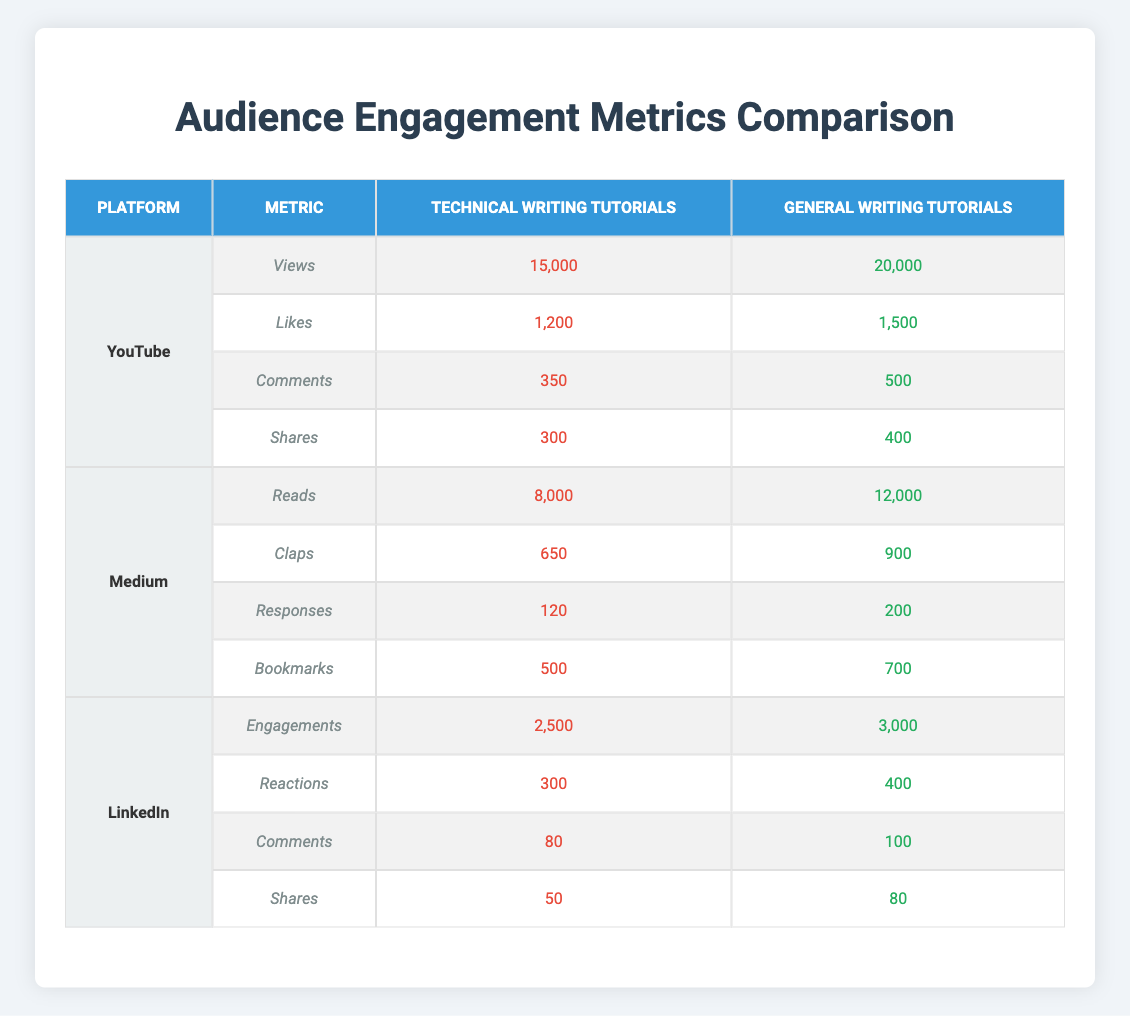What is the total number of Views for Technical Writing Tutorials on YouTube? The table shows that Technical Writing Tutorials on YouTube have 15,000 Views, as listed directly in the table.
Answer: 15,000 How many Claps did General Writing Tutorials receive on Medium? The table clearly indicates that General Writing Tutorials received 900 Claps on Medium.
Answer: 900 Which platform had the highest number of Shares for Technical Writing Tutorials? Comparing the Shares across platforms: YouTube has 300, Medium has none listed, and LinkedIn has 50. YouTube has the highest at 300 Shares.
Answer: YouTube What is the difference in Comments between Technical Writing and General Writing Tutorials on YouTube? On YouTube, Technical Writing Tutorials received 350 Comments, while General Writing Tutorials received 500. The difference is calculated as 500 - 350 = 150.
Answer: 150 True or False: General Writing Tutorials received more Engagements on LinkedIn compared to Technical Writing Tutorials. The table shows that General Writing Tutorials received 3,000 Engagements and Technical Writing Tutorials received 2,500 Engagements. Therefore, it is true.
Answer: True What is the total number of Reads and Bookmarks for Technical Writing Tutorials on Medium? The number of Reads is 8,000 and Bookmarks is 500 as per the table. The total is calculated as 8,000 + 500 = 8,500.
Answer: 8,500 Which writing type had more overall interactions across all metrics on Medium? Summarizing the metrics for Technical Writing Tutorials: 8,000 Reads + 650 Claps + 120 Responses + 500 Bookmarks = 9,270. For General Writing Tutorials: 12,000 Reads + 900 Claps + 200 Responses + 700 Bookmarks = 14,800. General Writing Tutorials had more interactions.
Answer: General Writing Tutorials What are the total number of Likes received for both Technical and General Writing Tutorials on YouTube? The table indicates that Technical Writing Tutorials received 1,200 Likes and General Writing Tutorials received 1,500 Likes. The total is 1,200 + 1,500 = 2,700.
Answer: 2,700 How many more Claps did General Writing Tutorials receive than Technical Writing Tutorials? From the table, General Writing Tutorials received 900 Claps and Technical Writing Tutorials received 650 Claps. The difference is 900 - 650 = 250.
Answer: 250 